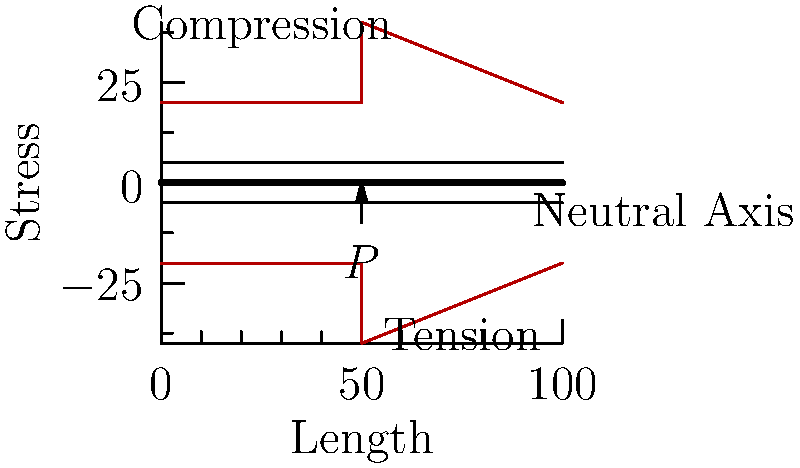As a biochemist skilled in experimental techniques, consider a steel I-beam subjected to a point load $P$ at its center. Given the stress distribution shown in the diagram, what can you conclude about the relationship between the maximum compressive stress ($\sigma_c$) and the maximum tensile stress ($\sigma_t$) in this loading scenario? To analyze this problem, let's approach it step-by-step:

1. Observe the stress distribution: The diagram shows a symmetrical stress distribution about the neutral axis of the I-beam.

2. Identify key features:
   - The point load $P$ is applied at the center of the beam.
   - The stress distribution is triangular, with maximum stress at the top and bottom surfaces.
   - The neutral axis (where stress is zero) is at the center of the beam's height.

3. Analyze the stress pattern:
   - Compression occurs above the neutral axis (positive y-direction).
   - Tension occurs below the neutral axis (negative y-direction).

4. Compare stress magnitudes:
   - The maximum compressive stress ($\sigma_c$) at the top fiber is equal in magnitude to the maximum tensile stress ($\sigma_t$) at the bottom fiber.
   - This equality is due to the symmetrical nature of the loading and the beam's geometry.

5. Relate to beam bending theory:
   - In pure bending, stress is proportional to the distance from the neutral axis.
   - For a symmetrical cross-section like an I-beam, this results in equal maximum stresses in tension and compression.

6. Consider material behavior:
   - Steel behaves similarly in tension and compression within its elastic limit, supporting the observed stress distribution.

From this analysis, we can conclude that the maximum compressive stress ($\sigma_c$) is equal in magnitude to the maximum tensile stress ($\sigma_t$) for this loading scenario.
Answer: $\sigma_c = \sigma_t$ 